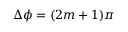Convert formula to latex. <formula><loc_0><loc_0><loc_500><loc_500>\Delta \phi = ( 2 m + 1 ) \pi</formula> 